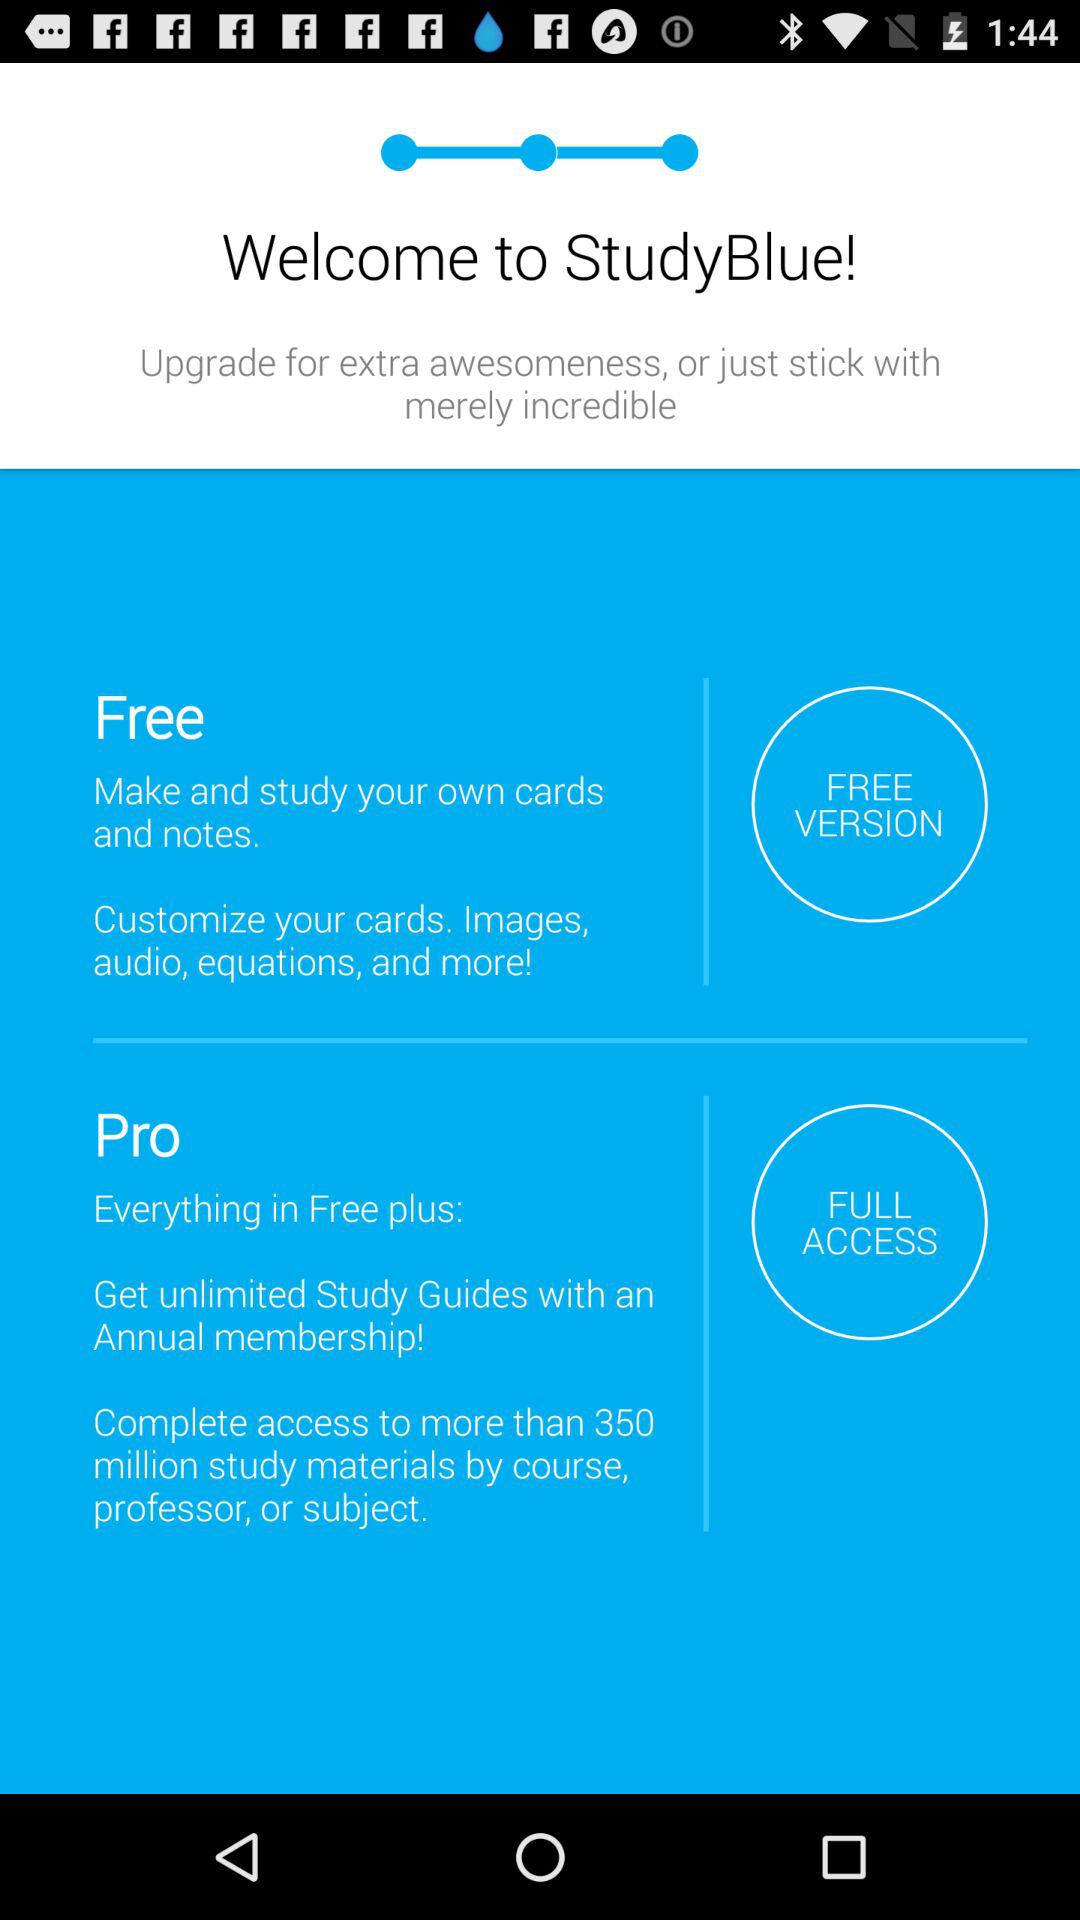What can we customize in the free version? You can customize "your cards, Images, audio, equations and more!". 